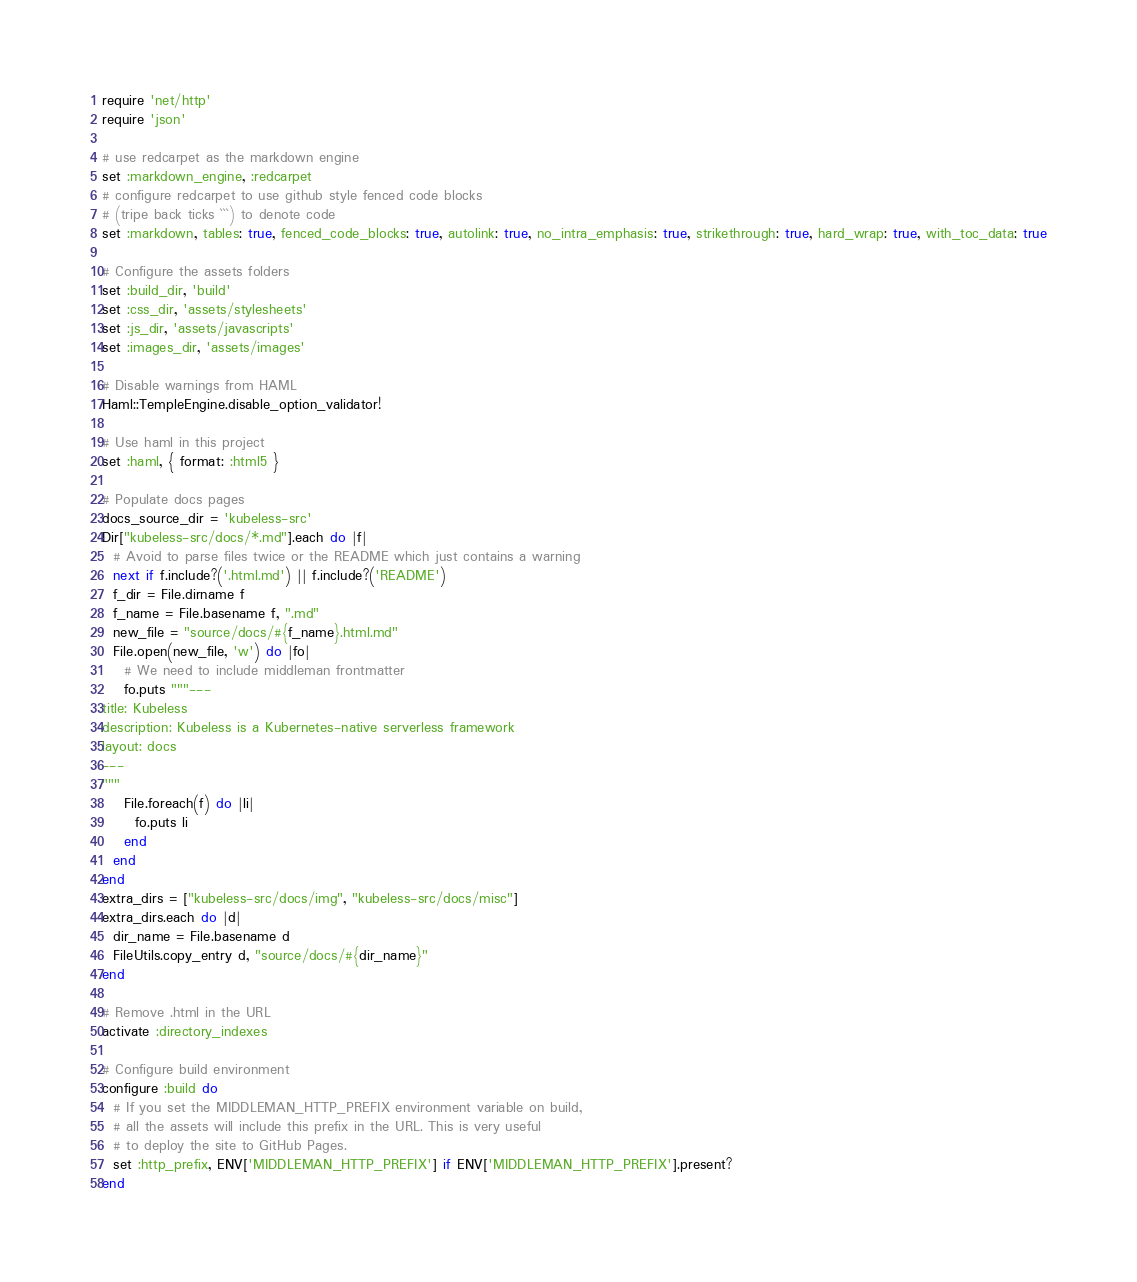Convert code to text. <code><loc_0><loc_0><loc_500><loc_500><_Ruby_>require 'net/http'
require 'json'

# use redcarpet as the markdown engine
set :markdown_engine, :redcarpet
# configure redcarpet to use github style fenced code blocks
# (tripe back ticks ```) to denote code
set :markdown, tables: true, fenced_code_blocks: true, autolink: true, no_intra_emphasis: true, strikethrough: true, hard_wrap: true, with_toc_data: true

# Configure the assets folders
set :build_dir, 'build'
set :css_dir, 'assets/stylesheets'
set :js_dir, 'assets/javascripts'
set :images_dir, 'assets/images'

# Disable warnings from HAML
Haml::TempleEngine.disable_option_validator!

# Use haml in this project
set :haml, { format: :html5 }

# Populate docs pages
docs_source_dir = 'kubeless-src'
Dir["kubeless-src/docs/*.md"].each do |f|
  # Avoid to parse files twice or the README which just contains a warning
  next if f.include?('.html.md') || f.include?('README')
  f_dir = File.dirname f
  f_name = File.basename f, ".md"
  new_file = "source/docs/#{f_name}.html.md"
  File.open(new_file, 'w') do |fo|
    # We need to include middleman frontmatter
    fo.puts """---
title: Kubeless
description: Kubeless is a Kubernetes-native serverless framework
layout: docs
---
"""
    File.foreach(f) do |li|
      fo.puts li
    end
  end
end
extra_dirs = ["kubeless-src/docs/img", "kubeless-src/docs/misc"]
extra_dirs.each do |d|
  dir_name = File.basename d
  FileUtils.copy_entry d, "source/docs/#{dir_name}"
end
 
# Remove .html in the URL
activate :directory_indexes

# Configure build environment
configure :build do
  # If you set the MIDDLEMAN_HTTP_PREFIX environment variable on build,
  # all the assets will include this prefix in the URL. This is very useful
  # to deploy the site to GitHub Pages.
  set :http_prefix, ENV['MIDDLEMAN_HTTP_PREFIX'] if ENV['MIDDLEMAN_HTTP_PREFIX'].present?
end
</code> 